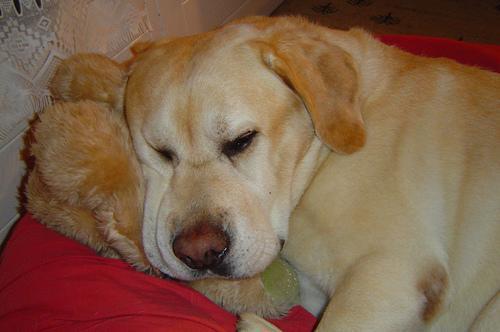How many dogs are there?
Give a very brief answer. 1. How many people are eating?
Give a very brief answer. 0. 